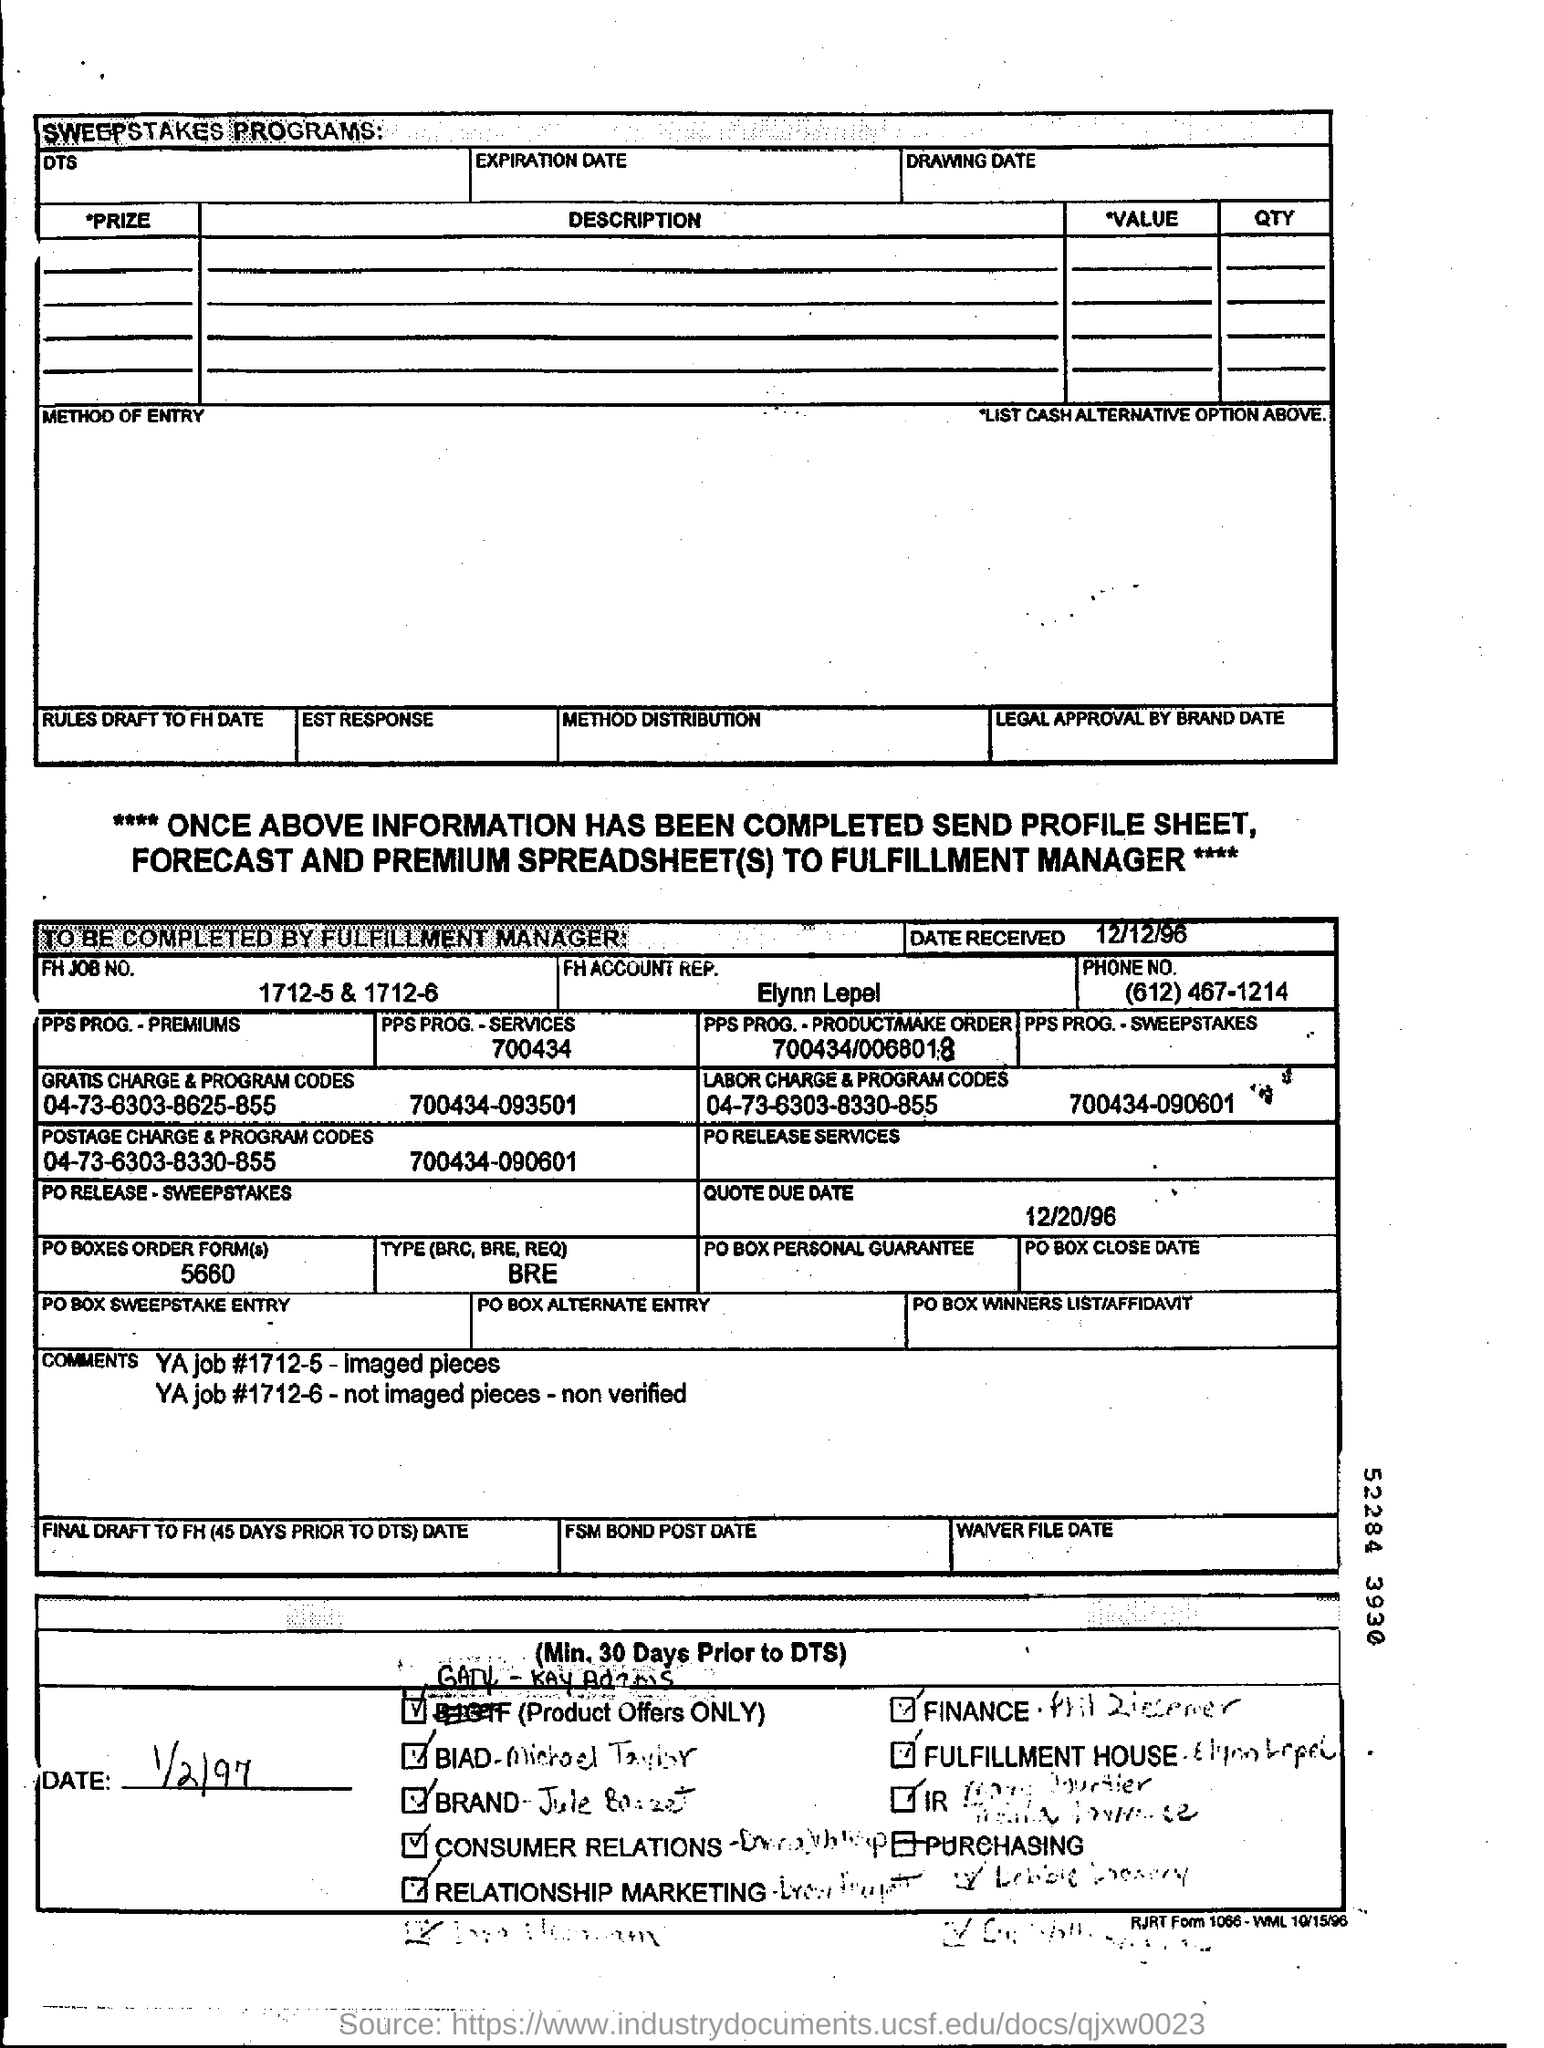What is the FH Job no. given in the form?
Offer a terse response. 1712-5 & 1715-6. Who is the FH account rep. mentioned in the form?
Offer a terse response. Elynn Lepel. What is the date received mentioned in the form?
Your response must be concise. 12/12/96. What is the quote due date given in the form?
Keep it short and to the point. 12/20/96. What is the phone no. of Elynn Lepel?
Give a very brief answer. (612) 467-1214. 